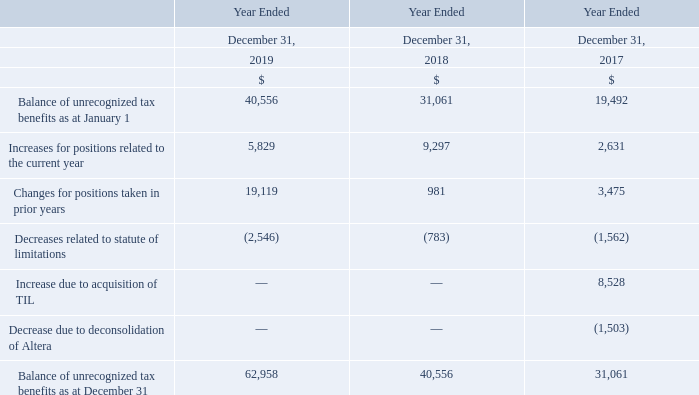The following is a roll-forward of the Company’s uncertain tax positions, recorded in other long-term liabilities, from January 1, 2017 to December 31, 2019:
The majority of the net increase for positions relates to the potential tax on freight income on changes for positions taken in prior years and an increased number of voyages for the year ended December 31, 2019.
The Company recognizes interest and penalties related to uncertain tax positions in income tax expense. The interest and penalties on unrecognized tax benefits are included in the roll-forward schedule above, and are increases of approximately $13.2 million, $9.2 million and $6.4 million in 2019, 2018 and 2017, respectively.
What led to net increase for positions for the year ended December 31, 2019? The majority of the net increase for positions relates to the potential tax on freight income on changes for positions taken in prior years and an increased number of voyages for the year ended december 31, 2019. What are the increases for the interest and penalties on unrecognized tax benefits in 2019, 2018 and 2017? The interest and penalties on unrecognized tax benefits are included in the roll-forward schedule above, and are increases of approximately $13.2 million, $9.2 million and $6.4 million in 2019, 2018 and 2017, respectively. What is included in the income tax expense? The company recognizes interest and penalties related to uncertain tax positions in income tax expense. What is the increase/ (decrease) in Balance of unrecognized tax benefits as at January 1 from December 31, 2019 to December 31, 2018?
Answer scale should be: million. 40,556-31,061
Answer: 9495. What is the increase/ (decrease) in Changes for positions taken in prior years from December 31, 2019 to December 31, 2018?
Answer scale should be: million. 19,119-981
Answer: 18138. What is the increase/ (decrease) in Decreases related to statute of limitations from December 31, 2019 to December 31, 2018?
Answer scale should be: million. 2,546-783
Answer: 1763. 